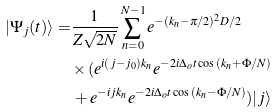<formula> <loc_0><loc_0><loc_500><loc_500>| \Psi _ { j } ( t ) \rangle = & \frac { 1 } { Z \sqrt { 2 N } } \sum _ { n = 0 } ^ { N - 1 } e ^ { - ( k _ { n } - \pi / 2 ) ^ { 2 } D / 2 } \\ & \times ( e ^ { i ( j - j _ { 0 } ) k _ { n } } e ^ { - 2 i \Delta _ { o } t \cos { ( k _ { n } + \Phi / N ) } } \\ & \, + e ^ { - i j k _ { n } } e ^ { - 2 i \Delta _ { o } t \cos { ( k _ { n } - \Phi / N ) } } ) | j \rangle</formula> 